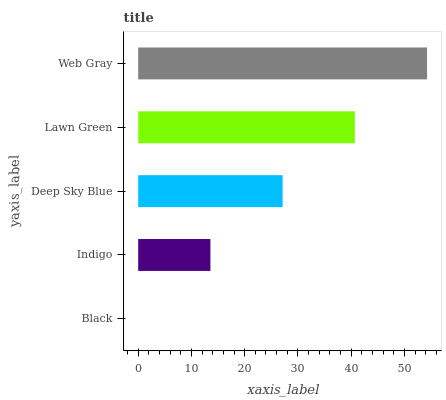Is Black the minimum?
Answer yes or no. Yes. Is Web Gray the maximum?
Answer yes or no. Yes. Is Indigo the minimum?
Answer yes or no. No. Is Indigo the maximum?
Answer yes or no. No. Is Indigo greater than Black?
Answer yes or no. Yes. Is Black less than Indigo?
Answer yes or no. Yes. Is Black greater than Indigo?
Answer yes or no. No. Is Indigo less than Black?
Answer yes or no. No. Is Deep Sky Blue the high median?
Answer yes or no. Yes. Is Deep Sky Blue the low median?
Answer yes or no. Yes. Is Black the high median?
Answer yes or no. No. Is Indigo the low median?
Answer yes or no. No. 